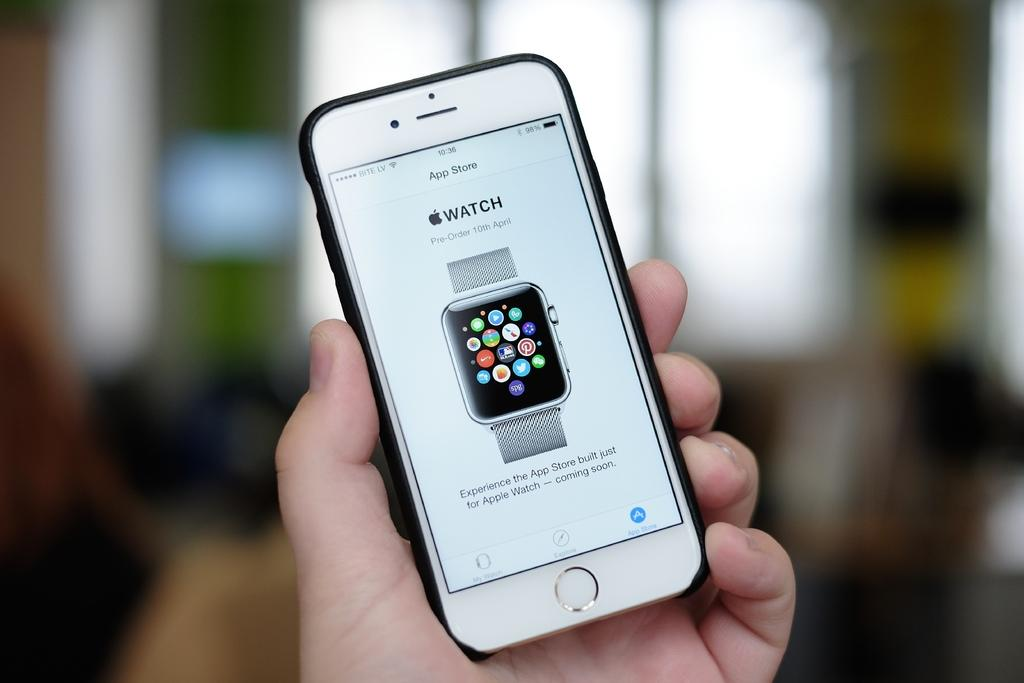Provide a one-sentence caption for the provided image. A hand is holding an iPhone which is displaying an Apple Watch on the App Store. 